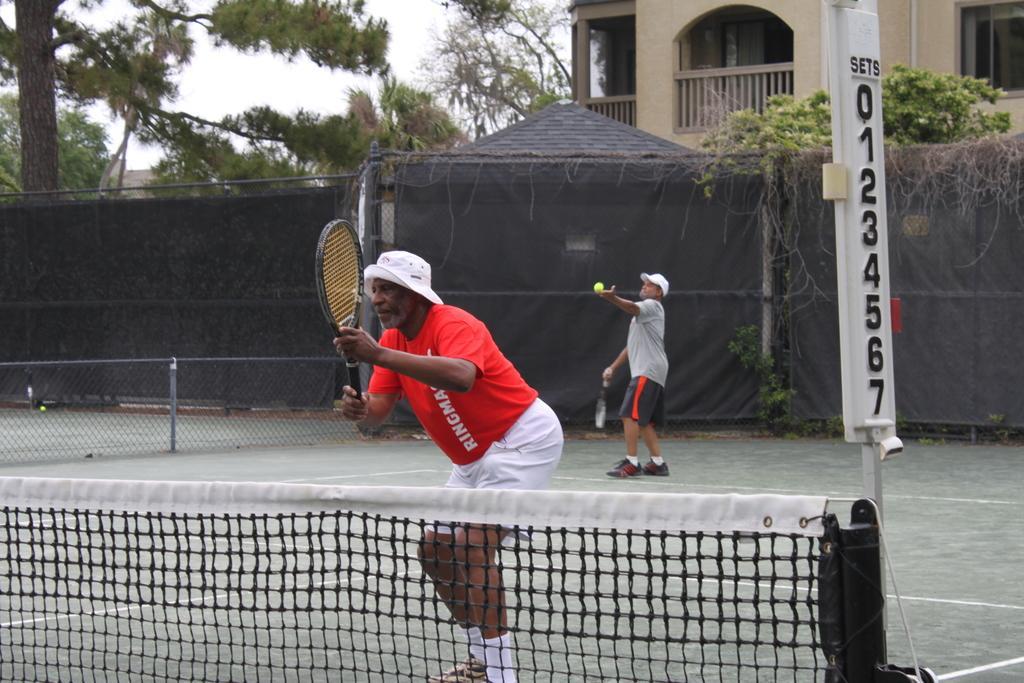Please provide a concise description of this image. In this image there is a person holding a tennis racket, behind the person there is another person is about to perform the action of serving the ball, behind them there are buildings and trees, in front of them there is the net. 